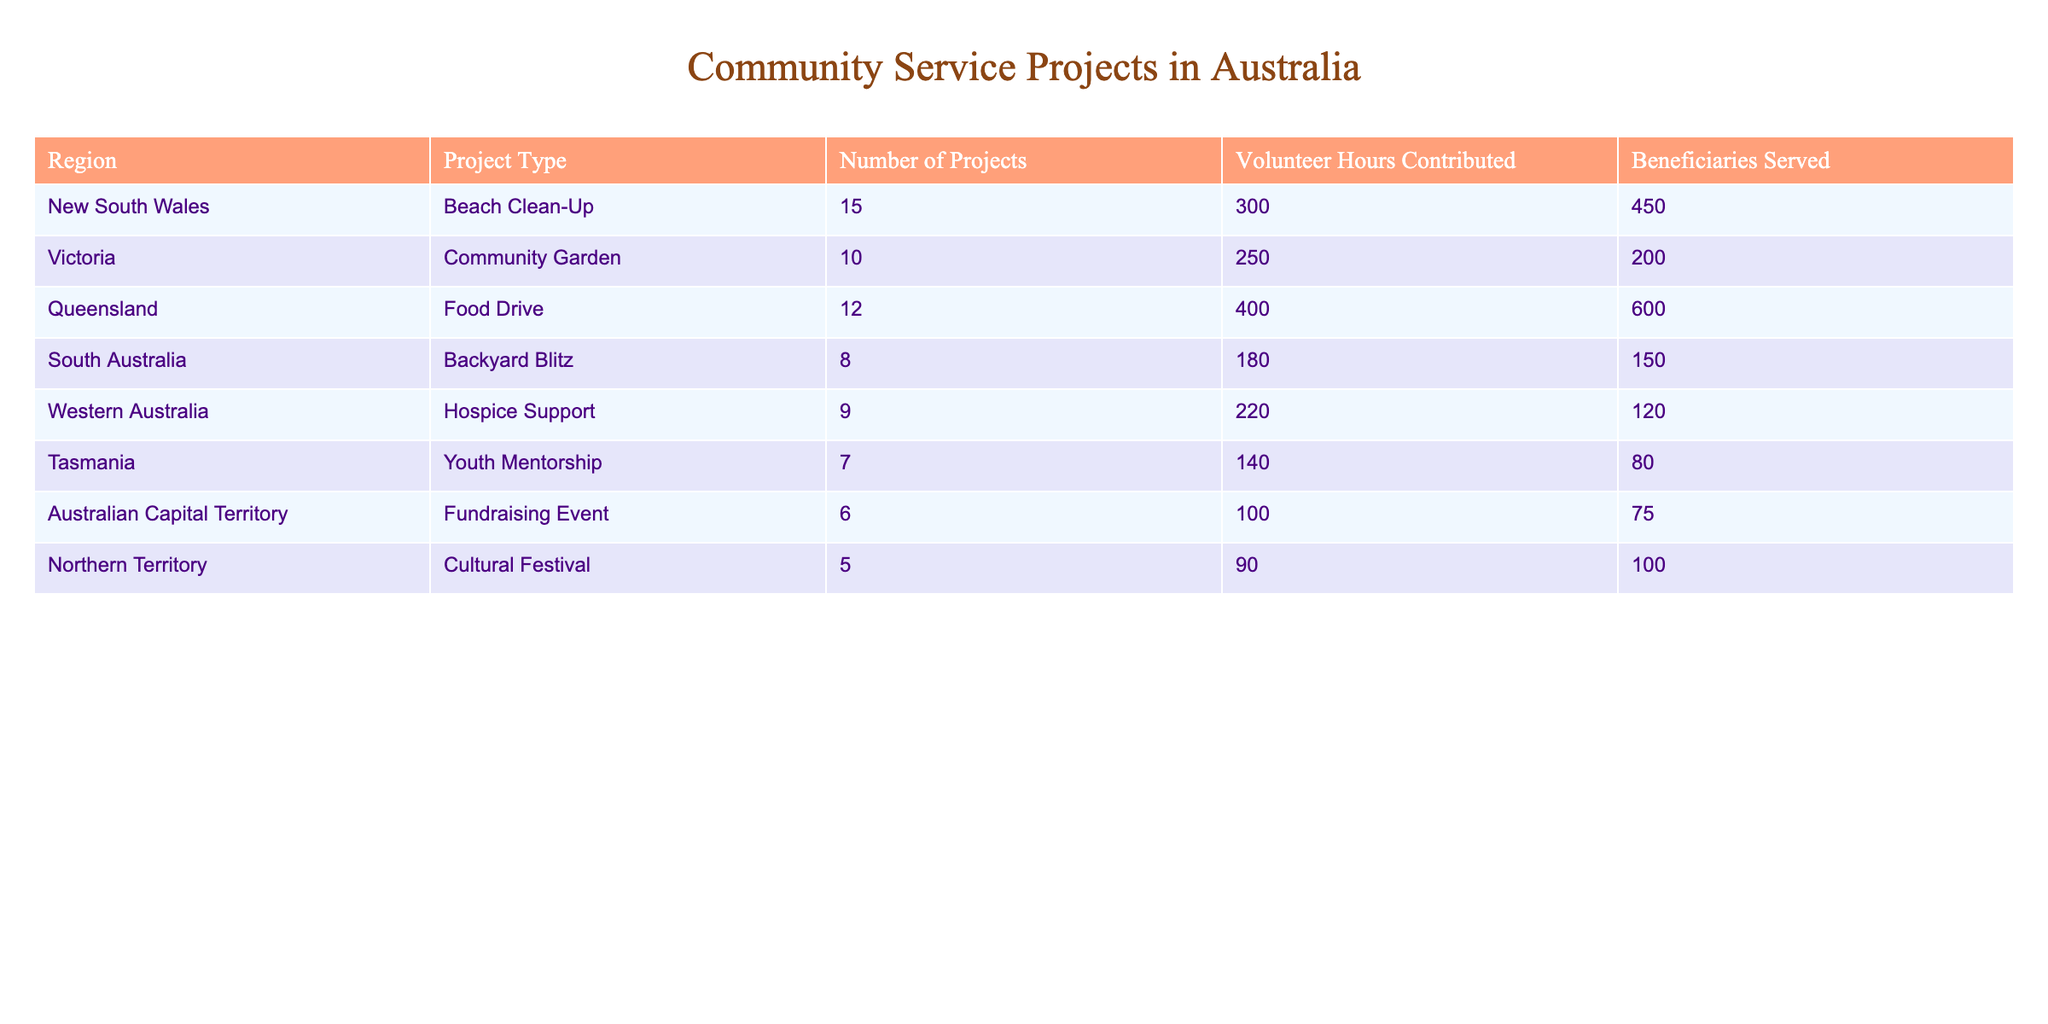What is the total number of community service projects organized in New South Wales? In the table, we look at the "Number of Projects" column for the New South Wales row, which shows 15 projects.
Answer: 15 Which region had the highest number of volunteer hours contributed? We compare the "Volunteer Hours Contributed" for each region. Queensland has the maximum with 400 hours.
Answer: Queensland Is it true that Tasmania organized more projects than the Australian Capital Territory? By checking the "Number of Projects" column, Tasmania has 7 projects while the Australian Capital Territory has 6 projects. Therefore, the statement is true.
Answer: Yes What is the average number of beneficiaries served per project across all regions? To find the average, we first sum the "Beneficiaries Served" (450 + 200 + 600 + 150 + 120 + 80 + 75 + 100 = 1775) and then divide by the total number of projects (15 + 10 + 12 + 8 + 9 + 7 + 6 + 5 = 72), resulting in an average of approximately 1775 / 72 = 24.7.
Answer: 24.7 Which project type has the least number of projects organized? By examining the "Number of Projects," we see that Northern Territory had the least with 5 projects.
Answer: Cultural Festival 